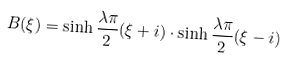Convert formula to latex. <formula><loc_0><loc_0><loc_500><loc_500>B ( \xi ) = \sinh \frac { \lambda \pi } { 2 } ( \xi + i ) \cdot \sinh \frac { \lambda \pi } { 2 } ( \xi - i )</formula> 